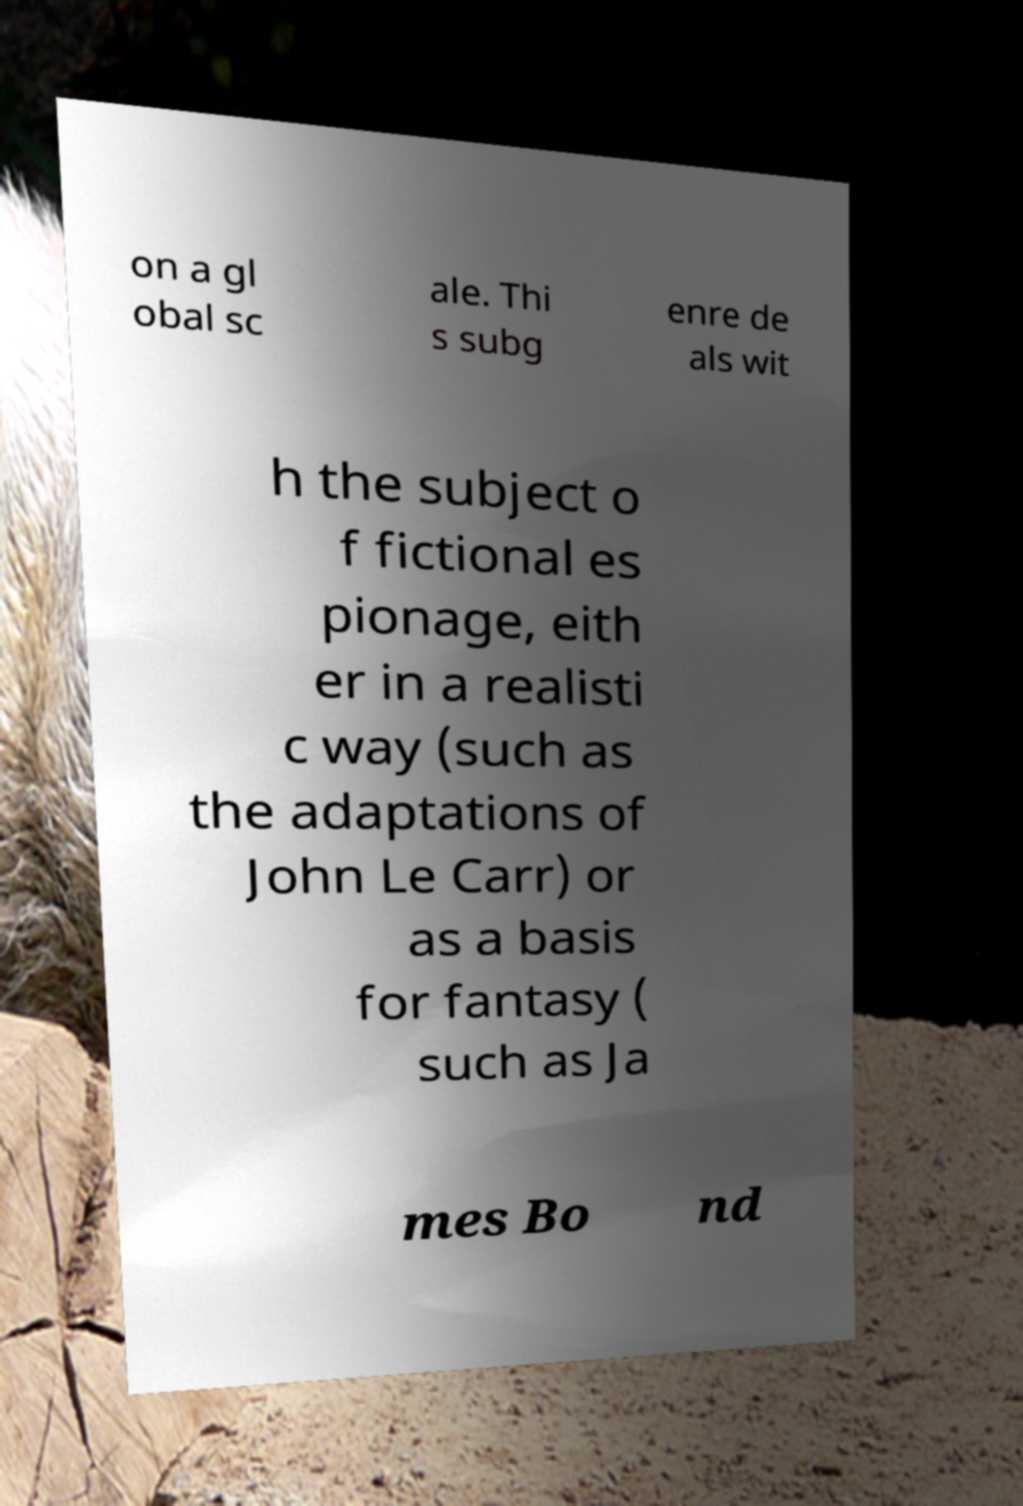Please read and relay the text visible in this image. What does it say? on a gl obal sc ale. Thi s subg enre de als wit h the subject o f fictional es pionage, eith er in a realisti c way (such as the adaptations of John Le Carr) or as a basis for fantasy ( such as Ja mes Bo nd 